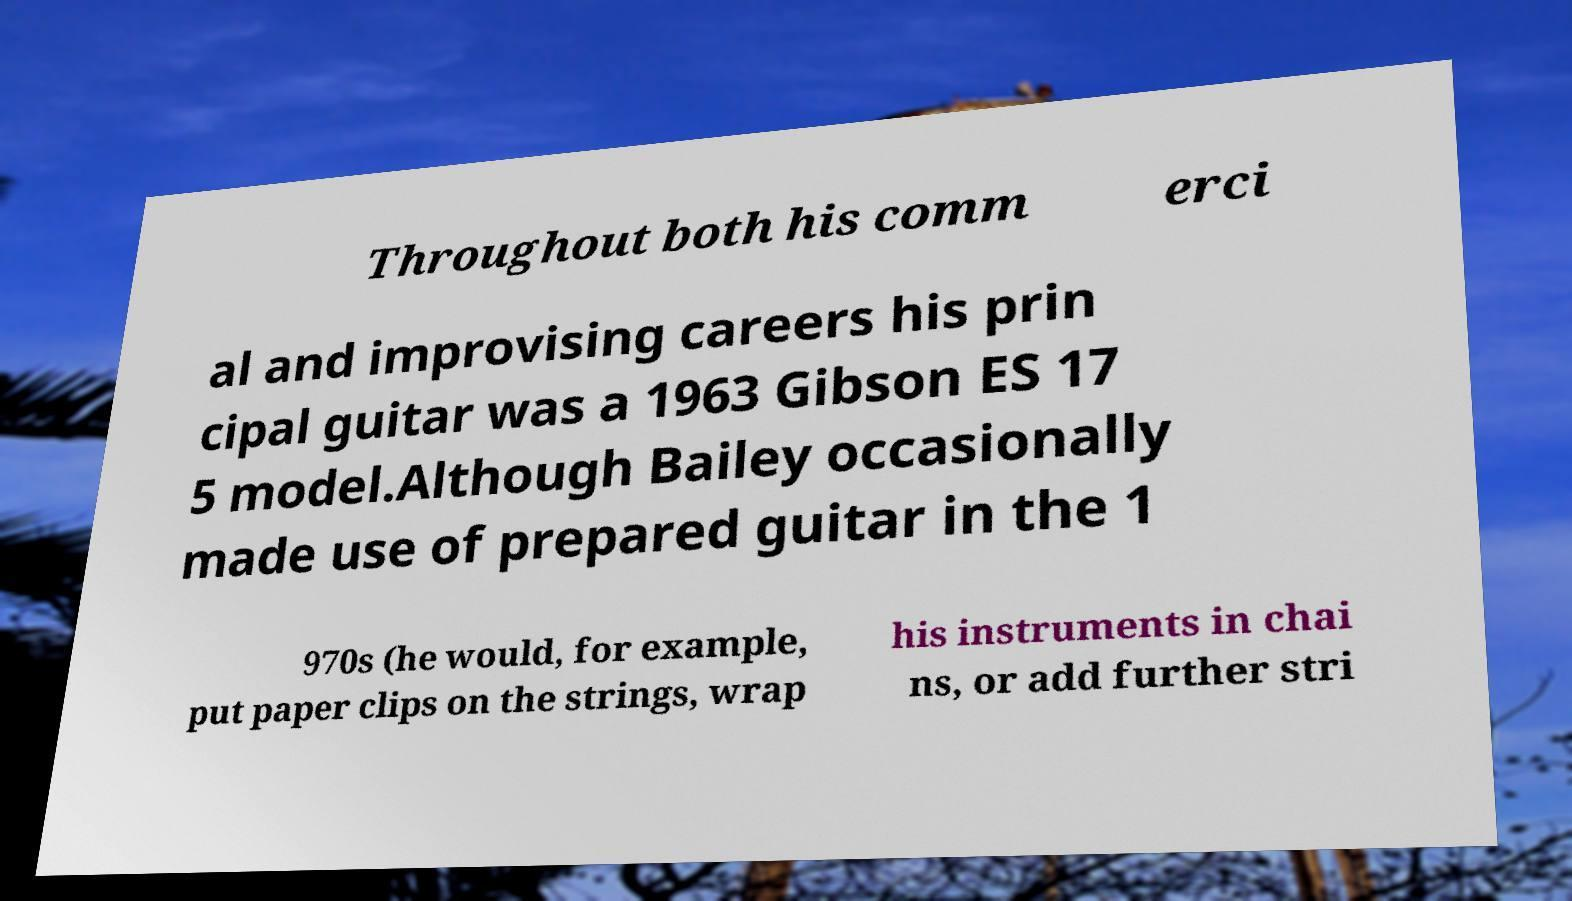Could you extract and type out the text from this image? Throughout both his comm erci al and improvising careers his prin cipal guitar was a 1963 Gibson ES 17 5 model.Although Bailey occasionally made use of prepared guitar in the 1 970s (he would, for example, put paper clips on the strings, wrap his instruments in chai ns, or add further stri 